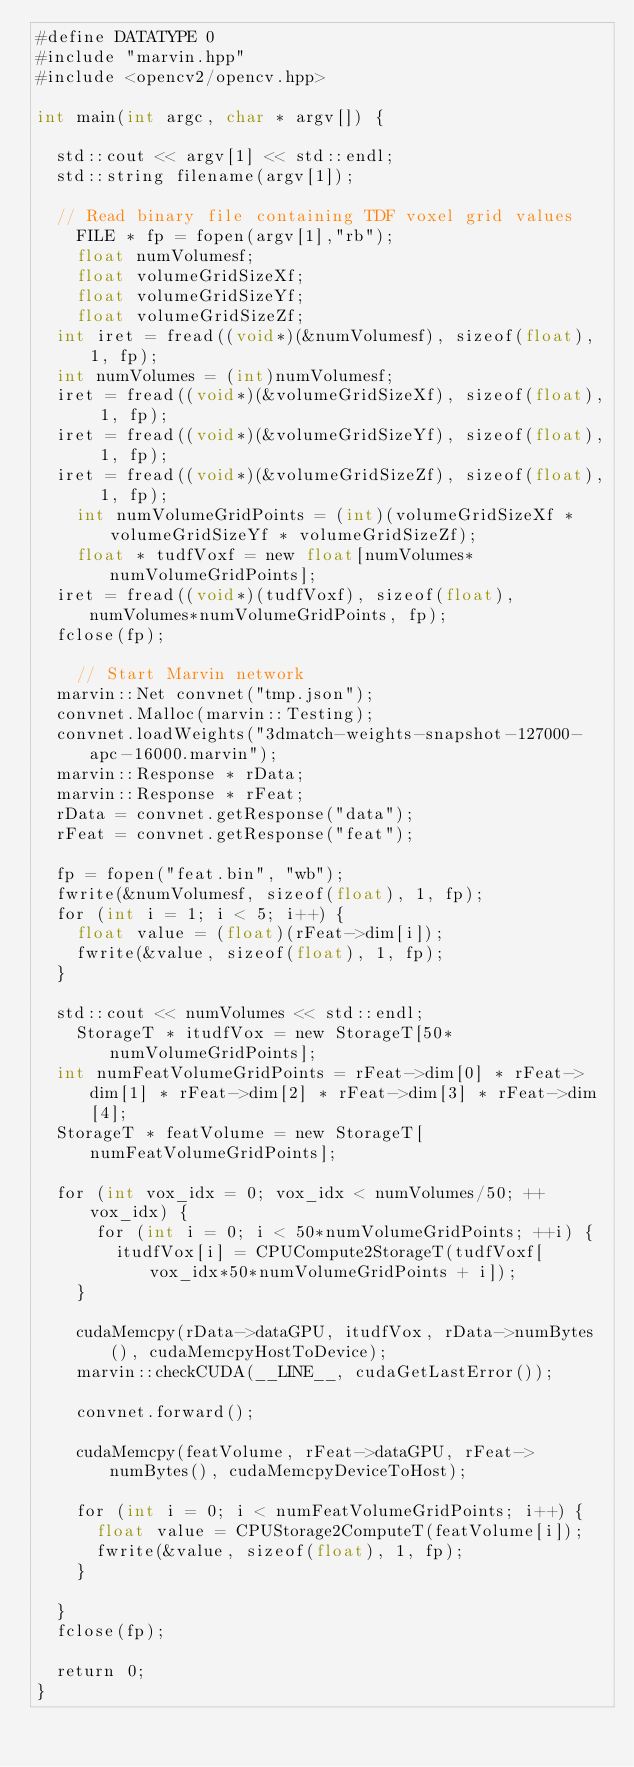Convert code to text. <code><loc_0><loc_0><loc_500><loc_500><_Cuda_>#define DATATYPE 0
#include "marvin.hpp"
#include <opencv2/opencv.hpp>

int main(int argc, char * argv[]) {

	std::cout << argv[1] << std::endl;
	std::string filename(argv[1]);

	// Read binary file containing TDF voxel grid values
    FILE * fp = fopen(argv[1],"rb");
    float numVolumesf;
    float volumeGridSizeXf;
    float volumeGridSizeYf;
    float volumeGridSizeZf;
	int iret = fread((void*)(&numVolumesf), sizeof(float), 1, fp);
	int numVolumes = (int)numVolumesf;
	iret = fread((void*)(&volumeGridSizeXf), sizeof(float), 1, fp);
	iret = fread((void*)(&volumeGridSizeYf), sizeof(float), 1, fp);
	iret = fread((void*)(&volumeGridSizeZf), sizeof(float), 1, fp);
    int numVolumeGridPoints = (int)(volumeGridSizeXf * volumeGridSizeYf * volumeGridSizeZf);
    float * tudfVoxf = new float[numVolumes*numVolumeGridPoints];
	iret = fread((void*)(tudfVoxf), sizeof(float), numVolumes*numVolumeGridPoints, fp);
	fclose(fp);

    // Start Marvin network
	marvin::Net convnet("tmp.json");
	convnet.Malloc(marvin::Testing);
	convnet.loadWeights("3dmatch-weights-snapshot-127000-apc-16000.marvin");
	marvin::Response * rData;
	marvin::Response * rFeat;
	rData = convnet.getResponse("data");
	rFeat = convnet.getResponse("feat");

	fp = fopen("feat.bin", "wb");
	fwrite(&numVolumesf, sizeof(float), 1, fp);
	for (int i = 1; i < 5; i++) {
		float value = (float)(rFeat->dim[i]);
		fwrite(&value, sizeof(float), 1, fp);
	}

	std::cout << numVolumes << std::endl;
    StorageT * itudfVox = new StorageT[50*numVolumeGridPoints];
	int numFeatVolumeGridPoints = rFeat->dim[0] * rFeat->dim[1] * rFeat->dim[2] * rFeat->dim[3] * rFeat->dim[4];
	StorageT * featVolume = new StorageT[numFeatVolumeGridPoints];

	for (int vox_idx = 0; vox_idx < numVolumes/50; ++vox_idx) {
	    for (int i = 0; i < 50*numVolumeGridPoints; ++i) {
	    	itudfVox[i] = CPUCompute2StorageT(tudfVoxf[vox_idx*50*numVolumeGridPoints + i]);
		}
	    
		cudaMemcpy(rData->dataGPU, itudfVox, rData->numBytes(), cudaMemcpyHostToDevice);
		marvin::checkCUDA(__LINE__, cudaGetLastError());

		convnet.forward();

		cudaMemcpy(featVolume, rFeat->dataGPU, rFeat->numBytes(), cudaMemcpyDeviceToHost);

		for (int i = 0; i < numFeatVolumeGridPoints; i++) {
			float value = CPUStorage2ComputeT(featVolume[i]);
			fwrite(&value, sizeof(float), 1, fp);
		}

	}
	fclose(fp);

	return 0;
}
















































</code> 